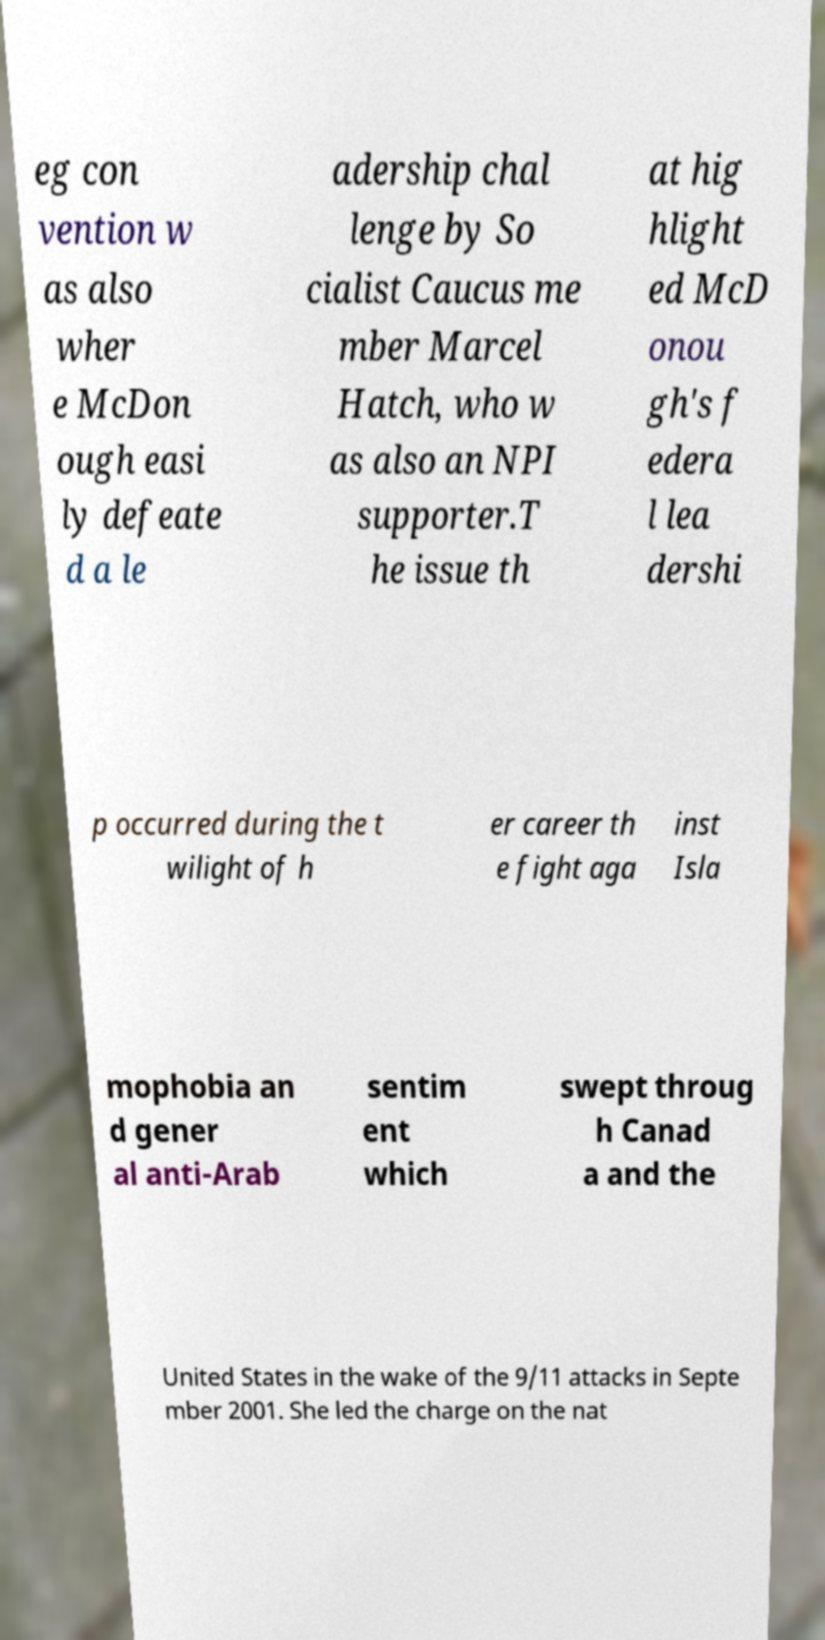I need the written content from this picture converted into text. Can you do that? eg con vention w as also wher e McDon ough easi ly defeate d a le adership chal lenge by So cialist Caucus me mber Marcel Hatch, who w as also an NPI supporter.T he issue th at hig hlight ed McD onou gh's f edera l lea dershi p occurred during the t wilight of h er career th e fight aga inst Isla mophobia an d gener al anti-Arab sentim ent which swept throug h Canad a and the United States in the wake of the 9/11 attacks in Septe mber 2001. She led the charge on the nat 